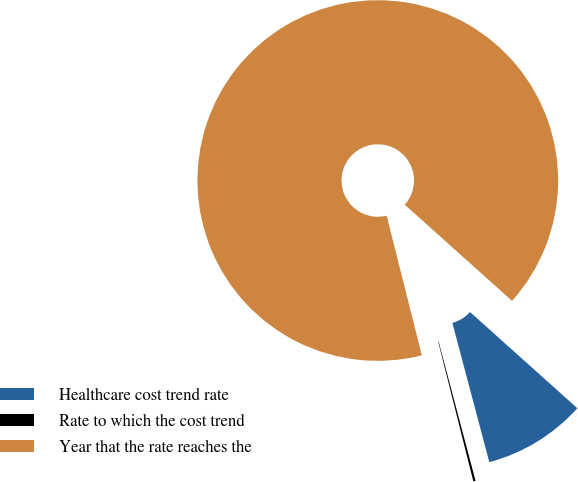<chart> <loc_0><loc_0><loc_500><loc_500><pie_chart><fcel>Healthcare cost trend rate<fcel>Rate to which the cost trend<fcel>Year that the rate reaches the<nl><fcel>9.24%<fcel>0.2%<fcel>90.56%<nl></chart> 